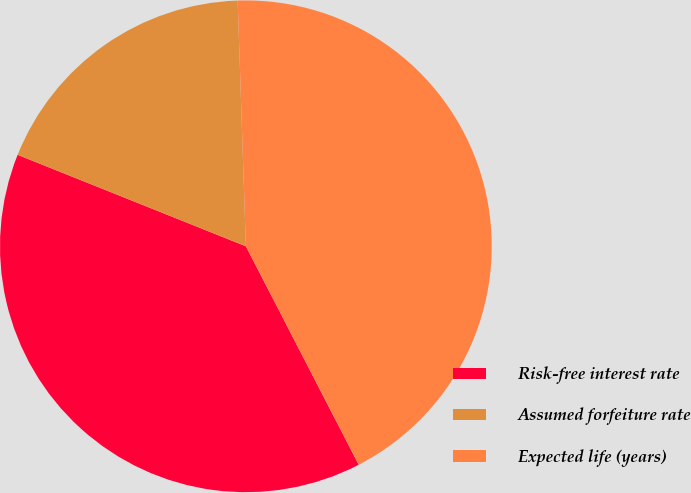Convert chart. <chart><loc_0><loc_0><loc_500><loc_500><pie_chart><fcel>Risk-free interest rate<fcel>Assumed forfeiture rate<fcel>Expected life (years)<nl><fcel>38.65%<fcel>18.4%<fcel>42.94%<nl></chart> 